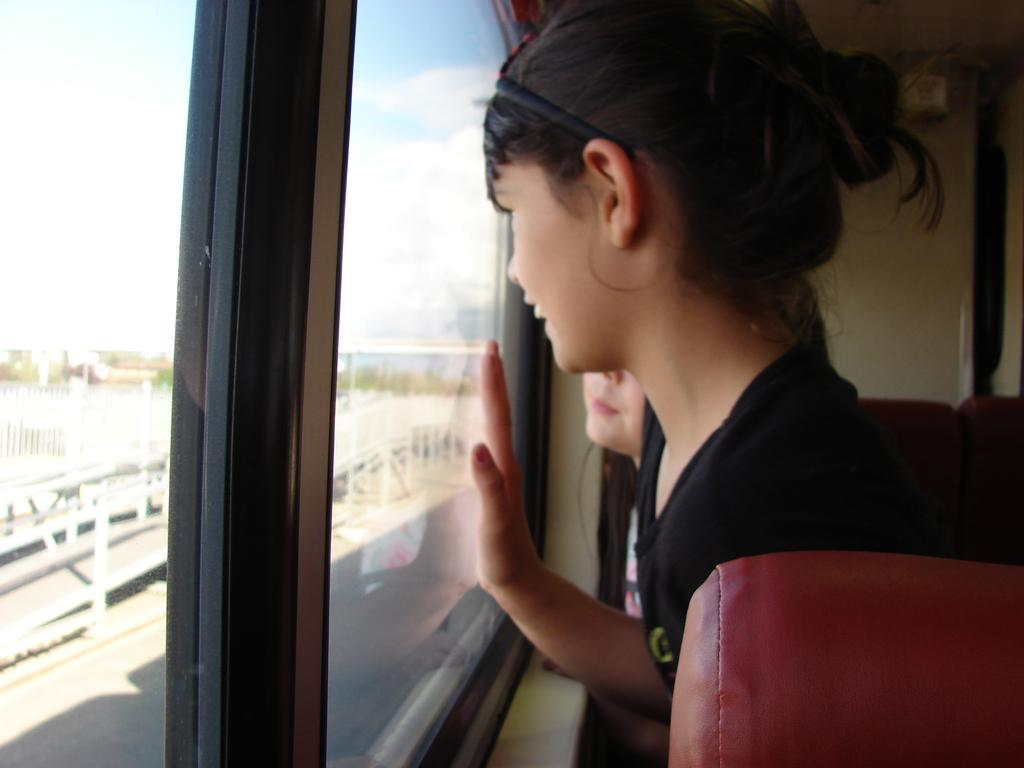How many people are in the image? There are two people in the image. Where are the people located in the image? The people are standing near the window on the right side of the image. What can be seen in the sky in the image? There are clouds visible in the sky on the left side of the image. What is the price of the vest worn by the person on the left side of the image? There is no person on the left side of the image, and no vest is visible in the image. 